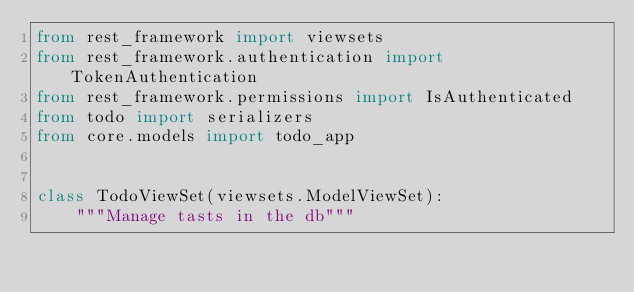<code> <loc_0><loc_0><loc_500><loc_500><_Python_>from rest_framework import viewsets
from rest_framework.authentication import TokenAuthentication
from rest_framework.permissions import IsAuthenticated
from todo import serializers
from core.models import todo_app


class TodoViewSet(viewsets.ModelViewSet):
    """Manage tasts in the db"""</code> 